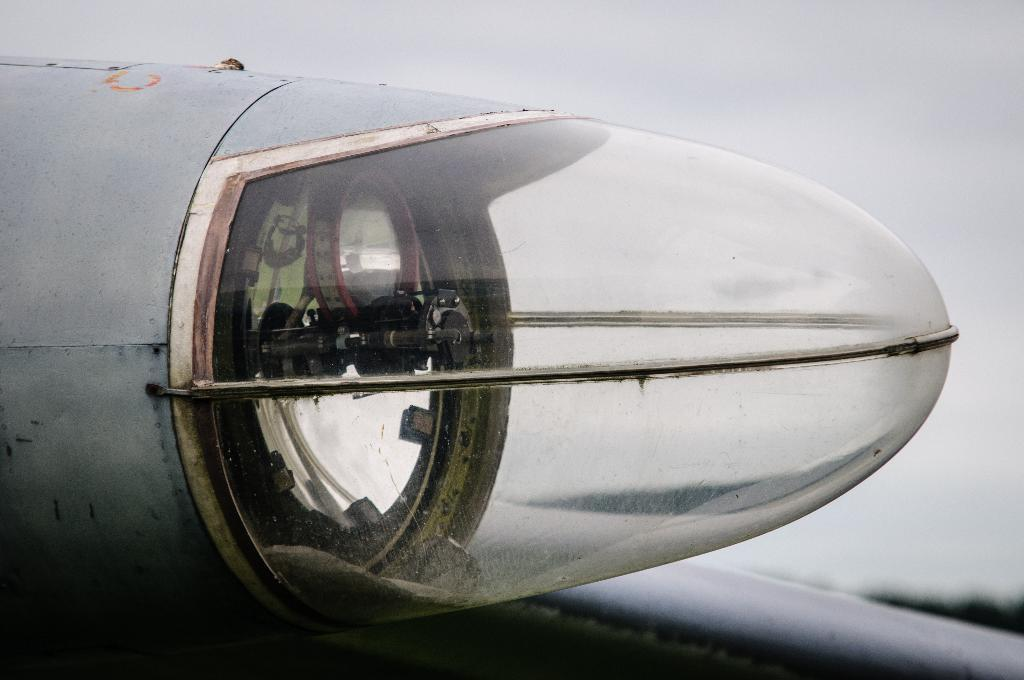What is the source of light in the image? There is a light from an aeroplane in the image. What is visible at the top of the image? The sky is visible at the top of the image. What reason does the aeroplane have for asking a question in the image? There is no indication in the image that the aeroplane is asking a question or has a reason for doing so. 